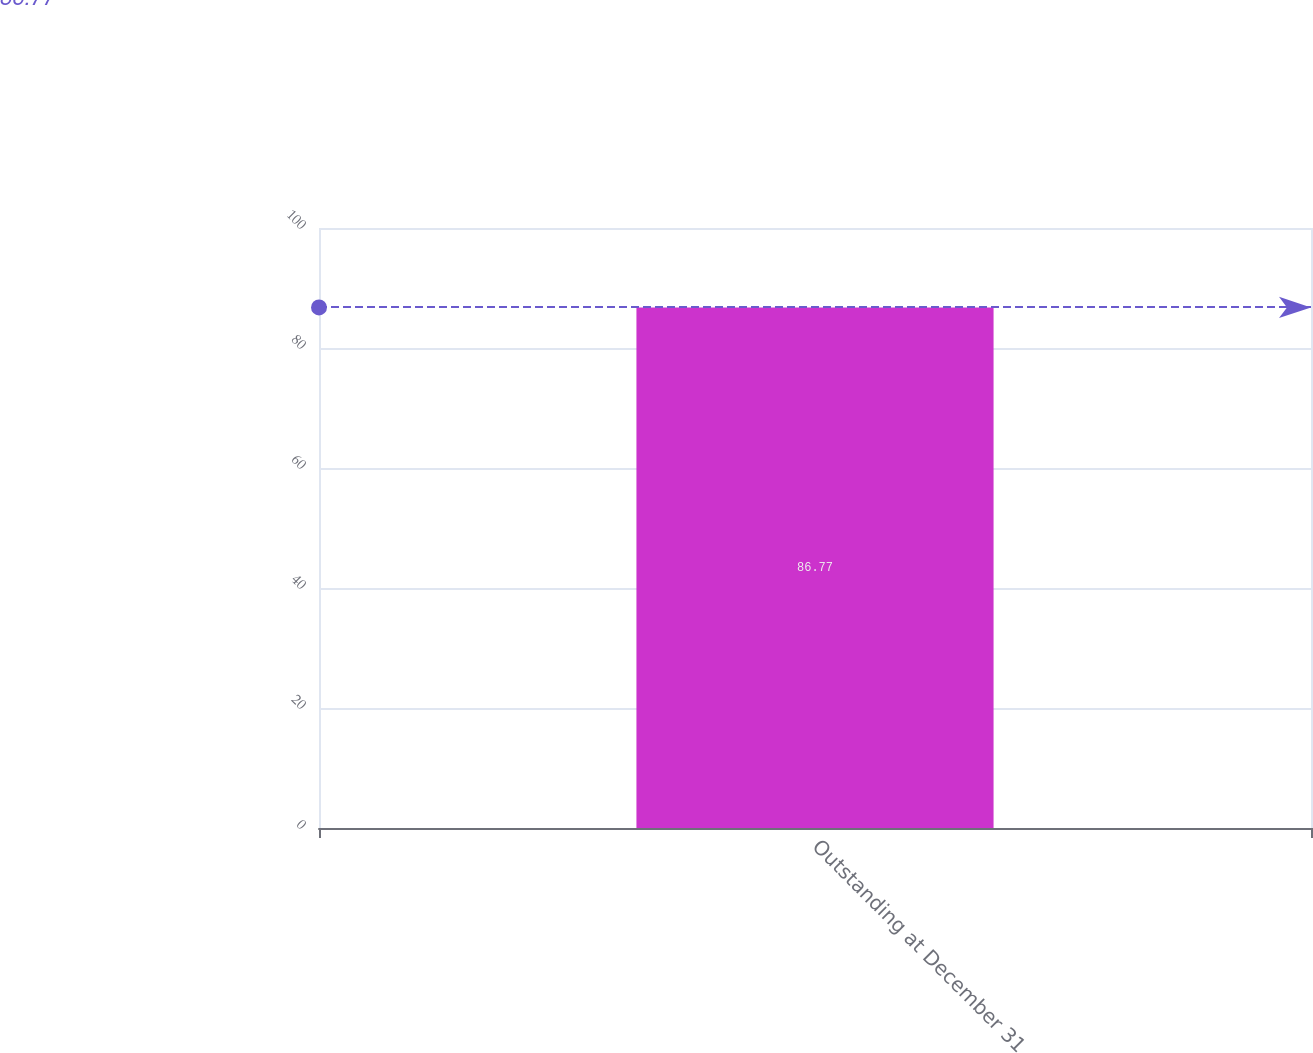<chart> <loc_0><loc_0><loc_500><loc_500><bar_chart><fcel>Outstanding at December 31<nl><fcel>86.77<nl></chart> 